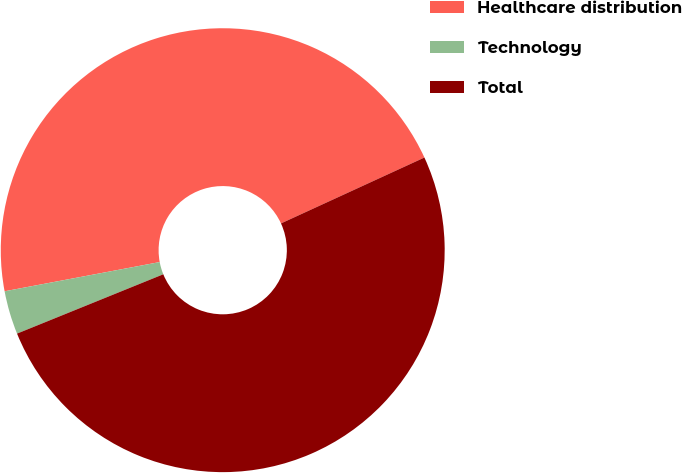Convert chart. <chart><loc_0><loc_0><loc_500><loc_500><pie_chart><fcel>Healthcare distribution<fcel>Technology<fcel>Total<nl><fcel>46.11%<fcel>3.17%<fcel>50.72%<nl></chart> 